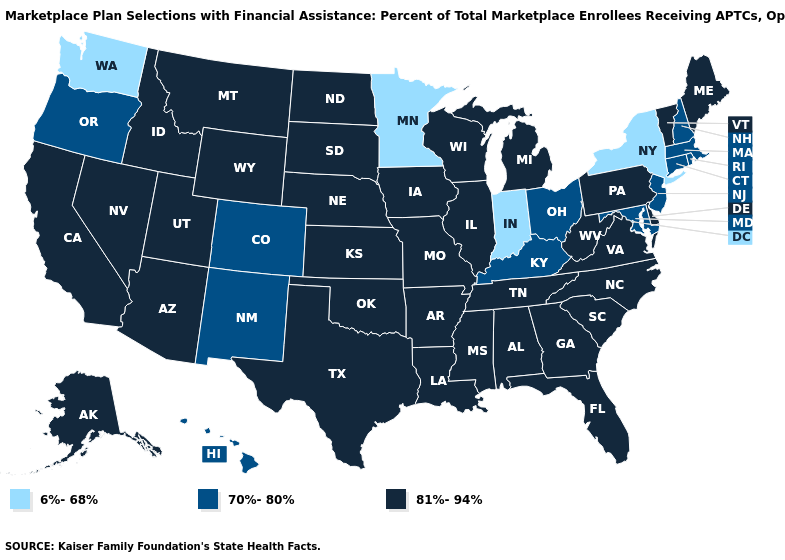What is the value of New Hampshire?
Give a very brief answer. 70%-80%. Does Vermont have the highest value in the Northeast?
Answer briefly. Yes. Does Colorado have a lower value than Washington?
Give a very brief answer. No. Does the first symbol in the legend represent the smallest category?
Give a very brief answer. Yes. What is the highest value in the USA?
Be succinct. 81%-94%. Does the first symbol in the legend represent the smallest category?
Short answer required. Yes. Which states have the lowest value in the Northeast?
Give a very brief answer. New York. Does the first symbol in the legend represent the smallest category?
Answer briefly. Yes. What is the value of Kentucky?
Quick response, please. 70%-80%. What is the value of Georgia?
Answer briefly. 81%-94%. Does the map have missing data?
Quick response, please. No. What is the value of New York?
Concise answer only. 6%-68%. Name the states that have a value in the range 70%-80%?
Answer briefly. Colorado, Connecticut, Hawaii, Kentucky, Maryland, Massachusetts, New Hampshire, New Jersey, New Mexico, Ohio, Oregon, Rhode Island. How many symbols are there in the legend?
Short answer required. 3. Name the states that have a value in the range 6%-68%?
Short answer required. Indiana, Minnesota, New York, Washington. 